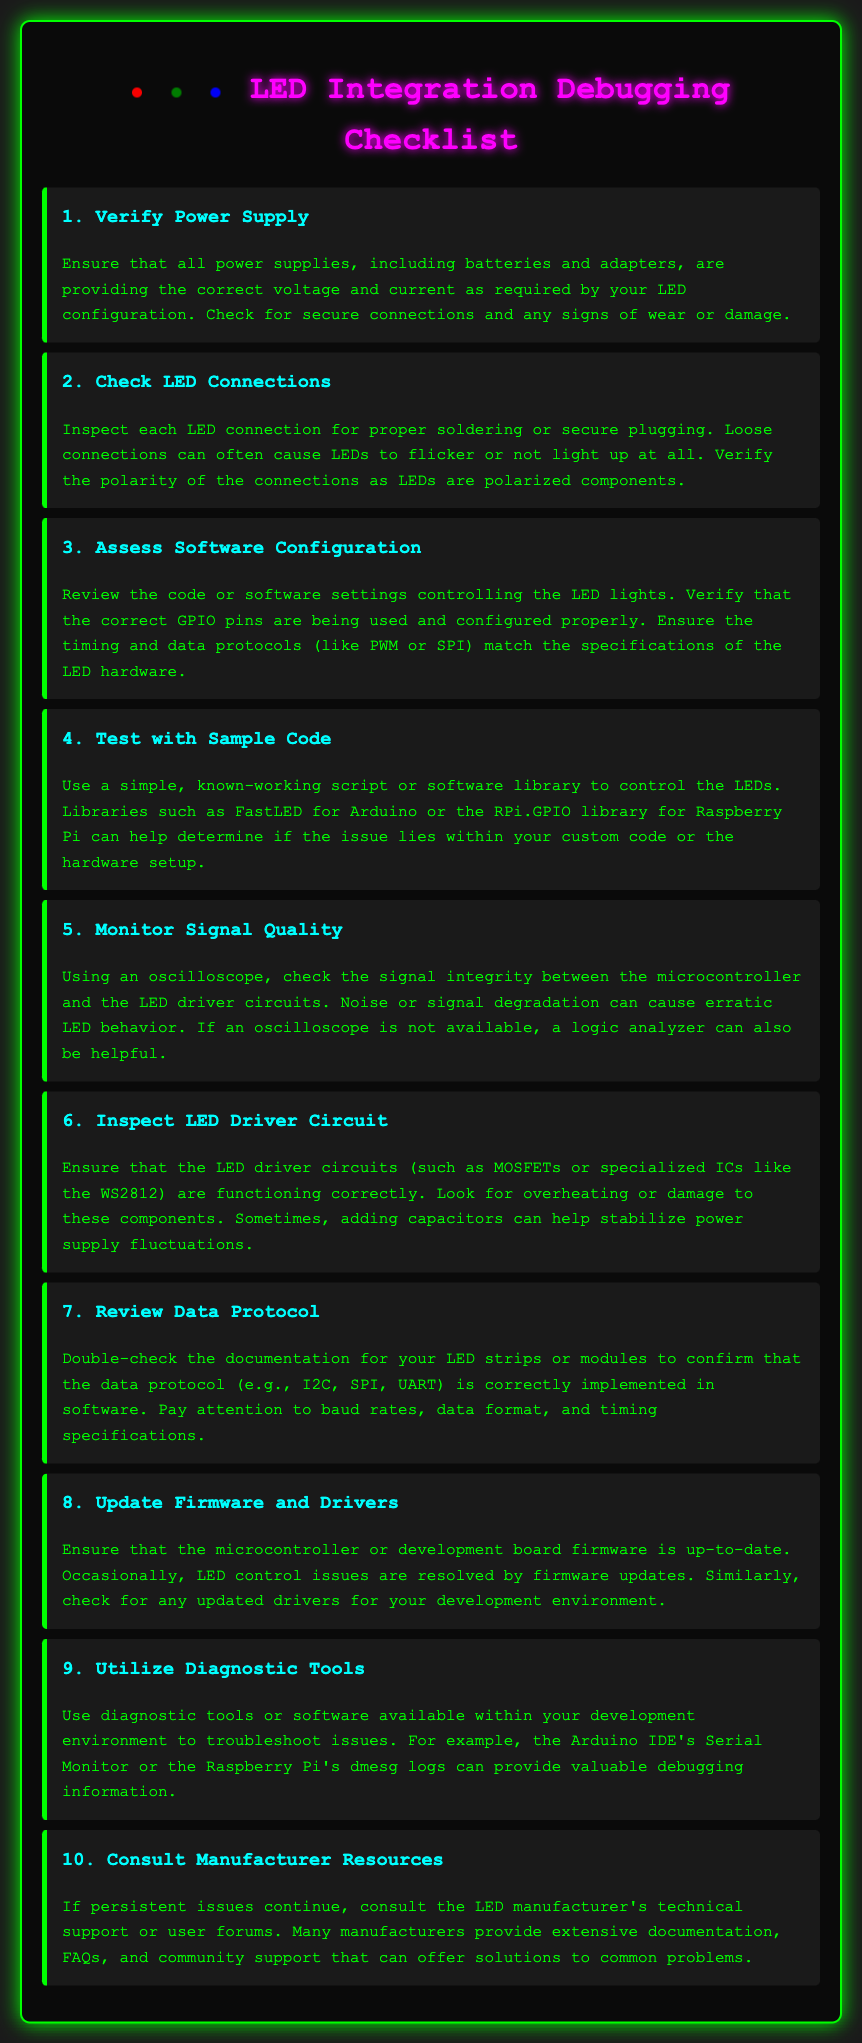what is the first item in the checklist? The first item in the checklist is "Verify Power Supply".
Answer: Verify Power Supply how many items are in the checklist? There are a total of ten items listed in the checklist.
Answer: 10 what is the color of the led that represents the title? The title contains multiple colors, but the first LED is red.
Answer: red which component should be used to test signal quality? An oscilloscope is recommended to check signal integrity.
Answer: oscilloscope what action should be taken if persistent issues continue? One should consult the LED manufacturer's technical support or user forums.
Answer: consult the LED manufacturer's technical support what protocol should be reviewed in item seven? The data protocol for the LED strips or modules should be reviewed.
Answer: data protocol what is suggested as a simple testing script for the LEDs? A simple, known-working script or software library like FastLED is suggested for testing.
Answer: FastLED what can help stabilize power supply fluctuations in the LED driver circuit? Adding capacitors can help stabilize power supply fluctuations.
Answer: adding capacitors which tool can be used for debugging information in the Arduino IDE? The Serial Monitor can be used for debugging information.
Answer: Serial Monitor 